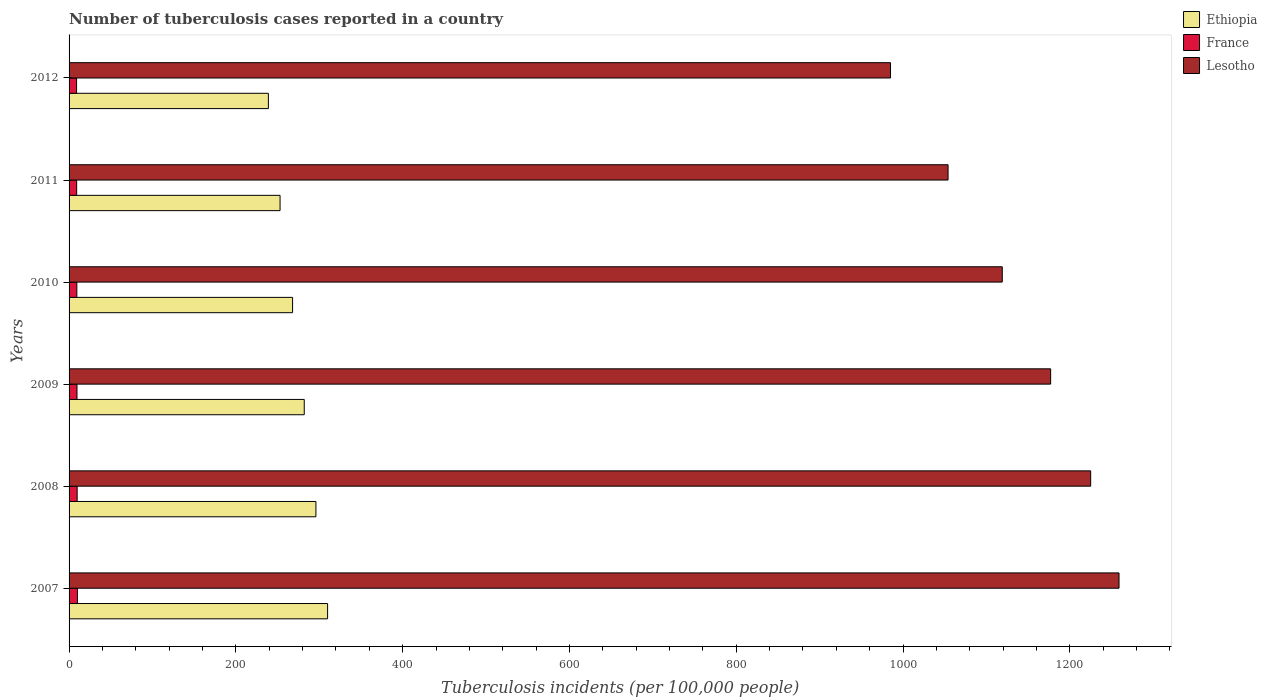How many different coloured bars are there?
Offer a very short reply. 3. Are the number of bars on each tick of the Y-axis equal?
Your answer should be very brief. Yes. How many bars are there on the 2nd tick from the top?
Give a very brief answer. 3. What is the label of the 4th group of bars from the top?
Your answer should be very brief. 2009. What is the number of tuberculosis cases reported in in France in 2009?
Ensure brevity in your answer.  9.5. Across all years, what is the maximum number of tuberculosis cases reported in in Lesotho?
Keep it short and to the point. 1259. In which year was the number of tuberculosis cases reported in in Ethiopia maximum?
Your answer should be compact. 2007. In which year was the number of tuberculosis cases reported in in Lesotho minimum?
Give a very brief answer. 2012. What is the total number of tuberculosis cases reported in in Lesotho in the graph?
Keep it short and to the point. 6819. What is the difference between the number of tuberculosis cases reported in in France in 2008 and that in 2010?
Your response must be concise. 0.4. What is the difference between the number of tuberculosis cases reported in in France in 2010 and the number of tuberculosis cases reported in in Ethiopia in 2012?
Your answer should be compact. -229.7. What is the average number of tuberculosis cases reported in in France per year?
Ensure brevity in your answer.  9.43. In the year 2009, what is the difference between the number of tuberculosis cases reported in in France and number of tuberculosis cases reported in in Lesotho?
Your answer should be compact. -1167.5. In how many years, is the number of tuberculosis cases reported in in France greater than 120 ?
Provide a succinct answer. 0. What is the ratio of the number of tuberculosis cases reported in in Lesotho in 2009 to that in 2012?
Make the answer very short. 1.19. What is the difference between the highest and the second highest number of tuberculosis cases reported in in Ethiopia?
Make the answer very short. 14. What is the difference between the highest and the lowest number of tuberculosis cases reported in in Ethiopia?
Give a very brief answer. 71. What does the 3rd bar from the top in 2007 represents?
Provide a short and direct response. Ethiopia. How many bars are there?
Your answer should be compact. 18. Are all the bars in the graph horizontal?
Keep it short and to the point. Yes. How many years are there in the graph?
Make the answer very short. 6. What is the difference between two consecutive major ticks on the X-axis?
Ensure brevity in your answer.  200. Are the values on the major ticks of X-axis written in scientific E-notation?
Keep it short and to the point. No. Where does the legend appear in the graph?
Give a very brief answer. Top right. How many legend labels are there?
Your answer should be compact. 3. How are the legend labels stacked?
Offer a very short reply. Vertical. What is the title of the graph?
Offer a terse response. Number of tuberculosis cases reported in a country. What is the label or title of the X-axis?
Your answer should be compact. Tuberculosis incidents (per 100,0 people). What is the Tuberculosis incidents (per 100,000 people) in Ethiopia in 2007?
Give a very brief answer. 310. What is the Tuberculosis incidents (per 100,000 people) of France in 2007?
Offer a terse response. 10. What is the Tuberculosis incidents (per 100,000 people) of Lesotho in 2007?
Provide a short and direct response. 1259. What is the Tuberculosis incidents (per 100,000 people) of Ethiopia in 2008?
Provide a short and direct response. 296. What is the Tuberculosis incidents (per 100,000 people) in France in 2008?
Offer a very short reply. 9.7. What is the Tuberculosis incidents (per 100,000 people) of Lesotho in 2008?
Give a very brief answer. 1225. What is the Tuberculosis incidents (per 100,000 people) in Ethiopia in 2009?
Provide a short and direct response. 282. What is the Tuberculosis incidents (per 100,000 people) of France in 2009?
Provide a short and direct response. 9.5. What is the Tuberculosis incidents (per 100,000 people) of Lesotho in 2009?
Your response must be concise. 1177. What is the Tuberculosis incidents (per 100,000 people) of Ethiopia in 2010?
Make the answer very short. 268. What is the Tuberculosis incidents (per 100,000 people) of Lesotho in 2010?
Provide a short and direct response. 1119. What is the Tuberculosis incidents (per 100,000 people) in Ethiopia in 2011?
Provide a succinct answer. 253. What is the Tuberculosis incidents (per 100,000 people) of Lesotho in 2011?
Your answer should be compact. 1054. What is the Tuberculosis incidents (per 100,000 people) in Ethiopia in 2012?
Ensure brevity in your answer.  239. What is the Tuberculosis incidents (per 100,000 people) in Lesotho in 2012?
Make the answer very short. 985. Across all years, what is the maximum Tuberculosis incidents (per 100,000 people) of Ethiopia?
Provide a succinct answer. 310. Across all years, what is the maximum Tuberculosis incidents (per 100,000 people) in France?
Keep it short and to the point. 10. Across all years, what is the maximum Tuberculosis incidents (per 100,000 people) in Lesotho?
Provide a succinct answer. 1259. Across all years, what is the minimum Tuberculosis incidents (per 100,000 people) in Ethiopia?
Offer a terse response. 239. Across all years, what is the minimum Tuberculosis incidents (per 100,000 people) in France?
Offer a terse response. 9. Across all years, what is the minimum Tuberculosis incidents (per 100,000 people) in Lesotho?
Ensure brevity in your answer.  985. What is the total Tuberculosis incidents (per 100,000 people) of Ethiopia in the graph?
Offer a terse response. 1648. What is the total Tuberculosis incidents (per 100,000 people) of France in the graph?
Give a very brief answer. 56.6. What is the total Tuberculosis incidents (per 100,000 people) of Lesotho in the graph?
Your answer should be very brief. 6819. What is the difference between the Tuberculosis incidents (per 100,000 people) in France in 2007 and that in 2008?
Ensure brevity in your answer.  0.3. What is the difference between the Tuberculosis incidents (per 100,000 people) in France in 2007 and that in 2009?
Offer a very short reply. 0.5. What is the difference between the Tuberculosis incidents (per 100,000 people) of Lesotho in 2007 and that in 2009?
Ensure brevity in your answer.  82. What is the difference between the Tuberculosis incidents (per 100,000 people) in Ethiopia in 2007 and that in 2010?
Your answer should be compact. 42. What is the difference between the Tuberculosis incidents (per 100,000 people) of France in 2007 and that in 2010?
Offer a terse response. 0.7. What is the difference between the Tuberculosis incidents (per 100,000 people) in Lesotho in 2007 and that in 2010?
Ensure brevity in your answer.  140. What is the difference between the Tuberculosis incidents (per 100,000 people) in Ethiopia in 2007 and that in 2011?
Offer a very short reply. 57. What is the difference between the Tuberculosis incidents (per 100,000 people) in France in 2007 and that in 2011?
Offer a terse response. 0.9. What is the difference between the Tuberculosis incidents (per 100,000 people) of Lesotho in 2007 and that in 2011?
Your answer should be very brief. 205. What is the difference between the Tuberculosis incidents (per 100,000 people) in France in 2007 and that in 2012?
Offer a very short reply. 1. What is the difference between the Tuberculosis incidents (per 100,000 people) of Lesotho in 2007 and that in 2012?
Ensure brevity in your answer.  274. What is the difference between the Tuberculosis incidents (per 100,000 people) of Ethiopia in 2008 and that in 2009?
Your response must be concise. 14. What is the difference between the Tuberculosis incidents (per 100,000 people) of France in 2008 and that in 2009?
Provide a succinct answer. 0.2. What is the difference between the Tuberculosis incidents (per 100,000 people) in Lesotho in 2008 and that in 2009?
Keep it short and to the point. 48. What is the difference between the Tuberculosis incidents (per 100,000 people) of France in 2008 and that in 2010?
Offer a very short reply. 0.4. What is the difference between the Tuberculosis incidents (per 100,000 people) in Lesotho in 2008 and that in 2010?
Make the answer very short. 106. What is the difference between the Tuberculosis incidents (per 100,000 people) of Ethiopia in 2008 and that in 2011?
Provide a succinct answer. 43. What is the difference between the Tuberculosis incidents (per 100,000 people) in Lesotho in 2008 and that in 2011?
Your answer should be very brief. 171. What is the difference between the Tuberculosis incidents (per 100,000 people) of Ethiopia in 2008 and that in 2012?
Ensure brevity in your answer.  57. What is the difference between the Tuberculosis incidents (per 100,000 people) in France in 2008 and that in 2012?
Provide a succinct answer. 0.7. What is the difference between the Tuberculosis incidents (per 100,000 people) of Lesotho in 2008 and that in 2012?
Offer a very short reply. 240. What is the difference between the Tuberculosis incidents (per 100,000 people) of France in 2009 and that in 2010?
Your answer should be very brief. 0.2. What is the difference between the Tuberculosis incidents (per 100,000 people) in Lesotho in 2009 and that in 2010?
Offer a terse response. 58. What is the difference between the Tuberculosis incidents (per 100,000 people) in France in 2009 and that in 2011?
Offer a very short reply. 0.4. What is the difference between the Tuberculosis incidents (per 100,000 people) of Lesotho in 2009 and that in 2011?
Offer a terse response. 123. What is the difference between the Tuberculosis incidents (per 100,000 people) of Ethiopia in 2009 and that in 2012?
Your answer should be compact. 43. What is the difference between the Tuberculosis incidents (per 100,000 people) of France in 2009 and that in 2012?
Offer a very short reply. 0.5. What is the difference between the Tuberculosis incidents (per 100,000 people) of Lesotho in 2009 and that in 2012?
Provide a short and direct response. 192. What is the difference between the Tuberculosis incidents (per 100,000 people) in France in 2010 and that in 2011?
Your answer should be compact. 0.2. What is the difference between the Tuberculosis incidents (per 100,000 people) of Ethiopia in 2010 and that in 2012?
Provide a short and direct response. 29. What is the difference between the Tuberculosis incidents (per 100,000 people) of France in 2010 and that in 2012?
Keep it short and to the point. 0.3. What is the difference between the Tuberculosis incidents (per 100,000 people) of Lesotho in 2010 and that in 2012?
Your response must be concise. 134. What is the difference between the Tuberculosis incidents (per 100,000 people) of Ethiopia in 2011 and that in 2012?
Your answer should be very brief. 14. What is the difference between the Tuberculosis incidents (per 100,000 people) in France in 2011 and that in 2012?
Make the answer very short. 0.1. What is the difference between the Tuberculosis incidents (per 100,000 people) in Lesotho in 2011 and that in 2012?
Give a very brief answer. 69. What is the difference between the Tuberculosis incidents (per 100,000 people) of Ethiopia in 2007 and the Tuberculosis incidents (per 100,000 people) of France in 2008?
Ensure brevity in your answer.  300.3. What is the difference between the Tuberculosis incidents (per 100,000 people) in Ethiopia in 2007 and the Tuberculosis incidents (per 100,000 people) in Lesotho in 2008?
Your answer should be compact. -915. What is the difference between the Tuberculosis incidents (per 100,000 people) of France in 2007 and the Tuberculosis incidents (per 100,000 people) of Lesotho in 2008?
Provide a short and direct response. -1215. What is the difference between the Tuberculosis incidents (per 100,000 people) of Ethiopia in 2007 and the Tuberculosis incidents (per 100,000 people) of France in 2009?
Provide a succinct answer. 300.5. What is the difference between the Tuberculosis incidents (per 100,000 people) in Ethiopia in 2007 and the Tuberculosis incidents (per 100,000 people) in Lesotho in 2009?
Make the answer very short. -867. What is the difference between the Tuberculosis incidents (per 100,000 people) of France in 2007 and the Tuberculosis incidents (per 100,000 people) of Lesotho in 2009?
Make the answer very short. -1167. What is the difference between the Tuberculosis incidents (per 100,000 people) of Ethiopia in 2007 and the Tuberculosis incidents (per 100,000 people) of France in 2010?
Keep it short and to the point. 300.7. What is the difference between the Tuberculosis incidents (per 100,000 people) in Ethiopia in 2007 and the Tuberculosis incidents (per 100,000 people) in Lesotho in 2010?
Your answer should be compact. -809. What is the difference between the Tuberculosis incidents (per 100,000 people) in France in 2007 and the Tuberculosis incidents (per 100,000 people) in Lesotho in 2010?
Give a very brief answer. -1109. What is the difference between the Tuberculosis incidents (per 100,000 people) of Ethiopia in 2007 and the Tuberculosis incidents (per 100,000 people) of France in 2011?
Offer a terse response. 300.9. What is the difference between the Tuberculosis incidents (per 100,000 people) of Ethiopia in 2007 and the Tuberculosis incidents (per 100,000 people) of Lesotho in 2011?
Provide a short and direct response. -744. What is the difference between the Tuberculosis incidents (per 100,000 people) of France in 2007 and the Tuberculosis incidents (per 100,000 people) of Lesotho in 2011?
Provide a succinct answer. -1044. What is the difference between the Tuberculosis incidents (per 100,000 people) in Ethiopia in 2007 and the Tuberculosis incidents (per 100,000 people) in France in 2012?
Your answer should be very brief. 301. What is the difference between the Tuberculosis incidents (per 100,000 people) in Ethiopia in 2007 and the Tuberculosis incidents (per 100,000 people) in Lesotho in 2012?
Ensure brevity in your answer.  -675. What is the difference between the Tuberculosis incidents (per 100,000 people) of France in 2007 and the Tuberculosis incidents (per 100,000 people) of Lesotho in 2012?
Provide a short and direct response. -975. What is the difference between the Tuberculosis incidents (per 100,000 people) of Ethiopia in 2008 and the Tuberculosis incidents (per 100,000 people) of France in 2009?
Your response must be concise. 286.5. What is the difference between the Tuberculosis incidents (per 100,000 people) of Ethiopia in 2008 and the Tuberculosis incidents (per 100,000 people) of Lesotho in 2009?
Ensure brevity in your answer.  -881. What is the difference between the Tuberculosis incidents (per 100,000 people) in France in 2008 and the Tuberculosis incidents (per 100,000 people) in Lesotho in 2009?
Make the answer very short. -1167.3. What is the difference between the Tuberculosis incidents (per 100,000 people) of Ethiopia in 2008 and the Tuberculosis incidents (per 100,000 people) of France in 2010?
Provide a short and direct response. 286.7. What is the difference between the Tuberculosis incidents (per 100,000 people) in Ethiopia in 2008 and the Tuberculosis incidents (per 100,000 people) in Lesotho in 2010?
Provide a succinct answer. -823. What is the difference between the Tuberculosis incidents (per 100,000 people) in France in 2008 and the Tuberculosis incidents (per 100,000 people) in Lesotho in 2010?
Ensure brevity in your answer.  -1109.3. What is the difference between the Tuberculosis incidents (per 100,000 people) of Ethiopia in 2008 and the Tuberculosis incidents (per 100,000 people) of France in 2011?
Offer a very short reply. 286.9. What is the difference between the Tuberculosis incidents (per 100,000 people) of Ethiopia in 2008 and the Tuberculosis incidents (per 100,000 people) of Lesotho in 2011?
Give a very brief answer. -758. What is the difference between the Tuberculosis incidents (per 100,000 people) in France in 2008 and the Tuberculosis incidents (per 100,000 people) in Lesotho in 2011?
Give a very brief answer. -1044.3. What is the difference between the Tuberculosis incidents (per 100,000 people) in Ethiopia in 2008 and the Tuberculosis incidents (per 100,000 people) in France in 2012?
Your answer should be very brief. 287. What is the difference between the Tuberculosis incidents (per 100,000 people) in Ethiopia in 2008 and the Tuberculosis incidents (per 100,000 people) in Lesotho in 2012?
Provide a succinct answer. -689. What is the difference between the Tuberculosis incidents (per 100,000 people) of France in 2008 and the Tuberculosis incidents (per 100,000 people) of Lesotho in 2012?
Keep it short and to the point. -975.3. What is the difference between the Tuberculosis incidents (per 100,000 people) of Ethiopia in 2009 and the Tuberculosis incidents (per 100,000 people) of France in 2010?
Offer a terse response. 272.7. What is the difference between the Tuberculosis incidents (per 100,000 people) in Ethiopia in 2009 and the Tuberculosis incidents (per 100,000 people) in Lesotho in 2010?
Keep it short and to the point. -837. What is the difference between the Tuberculosis incidents (per 100,000 people) of France in 2009 and the Tuberculosis incidents (per 100,000 people) of Lesotho in 2010?
Offer a very short reply. -1109.5. What is the difference between the Tuberculosis incidents (per 100,000 people) of Ethiopia in 2009 and the Tuberculosis incidents (per 100,000 people) of France in 2011?
Your answer should be very brief. 272.9. What is the difference between the Tuberculosis incidents (per 100,000 people) in Ethiopia in 2009 and the Tuberculosis incidents (per 100,000 people) in Lesotho in 2011?
Your response must be concise. -772. What is the difference between the Tuberculosis incidents (per 100,000 people) in France in 2009 and the Tuberculosis incidents (per 100,000 people) in Lesotho in 2011?
Give a very brief answer. -1044.5. What is the difference between the Tuberculosis incidents (per 100,000 people) of Ethiopia in 2009 and the Tuberculosis incidents (per 100,000 people) of France in 2012?
Your response must be concise. 273. What is the difference between the Tuberculosis incidents (per 100,000 people) of Ethiopia in 2009 and the Tuberculosis incidents (per 100,000 people) of Lesotho in 2012?
Your response must be concise. -703. What is the difference between the Tuberculosis incidents (per 100,000 people) of France in 2009 and the Tuberculosis incidents (per 100,000 people) of Lesotho in 2012?
Make the answer very short. -975.5. What is the difference between the Tuberculosis incidents (per 100,000 people) of Ethiopia in 2010 and the Tuberculosis incidents (per 100,000 people) of France in 2011?
Offer a very short reply. 258.9. What is the difference between the Tuberculosis incidents (per 100,000 people) in Ethiopia in 2010 and the Tuberculosis incidents (per 100,000 people) in Lesotho in 2011?
Give a very brief answer. -786. What is the difference between the Tuberculosis incidents (per 100,000 people) of France in 2010 and the Tuberculosis incidents (per 100,000 people) of Lesotho in 2011?
Provide a succinct answer. -1044.7. What is the difference between the Tuberculosis incidents (per 100,000 people) in Ethiopia in 2010 and the Tuberculosis incidents (per 100,000 people) in France in 2012?
Your answer should be very brief. 259. What is the difference between the Tuberculosis incidents (per 100,000 people) of Ethiopia in 2010 and the Tuberculosis incidents (per 100,000 people) of Lesotho in 2012?
Offer a terse response. -717. What is the difference between the Tuberculosis incidents (per 100,000 people) of France in 2010 and the Tuberculosis incidents (per 100,000 people) of Lesotho in 2012?
Keep it short and to the point. -975.7. What is the difference between the Tuberculosis incidents (per 100,000 people) of Ethiopia in 2011 and the Tuberculosis incidents (per 100,000 people) of France in 2012?
Make the answer very short. 244. What is the difference between the Tuberculosis incidents (per 100,000 people) in Ethiopia in 2011 and the Tuberculosis incidents (per 100,000 people) in Lesotho in 2012?
Offer a terse response. -732. What is the difference between the Tuberculosis incidents (per 100,000 people) of France in 2011 and the Tuberculosis incidents (per 100,000 people) of Lesotho in 2012?
Ensure brevity in your answer.  -975.9. What is the average Tuberculosis incidents (per 100,000 people) of Ethiopia per year?
Offer a very short reply. 274.67. What is the average Tuberculosis incidents (per 100,000 people) of France per year?
Provide a succinct answer. 9.43. What is the average Tuberculosis incidents (per 100,000 people) of Lesotho per year?
Your response must be concise. 1136.5. In the year 2007, what is the difference between the Tuberculosis incidents (per 100,000 people) of Ethiopia and Tuberculosis incidents (per 100,000 people) of France?
Make the answer very short. 300. In the year 2007, what is the difference between the Tuberculosis incidents (per 100,000 people) in Ethiopia and Tuberculosis incidents (per 100,000 people) in Lesotho?
Keep it short and to the point. -949. In the year 2007, what is the difference between the Tuberculosis incidents (per 100,000 people) in France and Tuberculosis incidents (per 100,000 people) in Lesotho?
Ensure brevity in your answer.  -1249. In the year 2008, what is the difference between the Tuberculosis incidents (per 100,000 people) in Ethiopia and Tuberculosis incidents (per 100,000 people) in France?
Make the answer very short. 286.3. In the year 2008, what is the difference between the Tuberculosis incidents (per 100,000 people) in Ethiopia and Tuberculosis incidents (per 100,000 people) in Lesotho?
Your response must be concise. -929. In the year 2008, what is the difference between the Tuberculosis incidents (per 100,000 people) in France and Tuberculosis incidents (per 100,000 people) in Lesotho?
Ensure brevity in your answer.  -1215.3. In the year 2009, what is the difference between the Tuberculosis incidents (per 100,000 people) in Ethiopia and Tuberculosis incidents (per 100,000 people) in France?
Offer a terse response. 272.5. In the year 2009, what is the difference between the Tuberculosis incidents (per 100,000 people) in Ethiopia and Tuberculosis incidents (per 100,000 people) in Lesotho?
Your response must be concise. -895. In the year 2009, what is the difference between the Tuberculosis incidents (per 100,000 people) in France and Tuberculosis incidents (per 100,000 people) in Lesotho?
Your response must be concise. -1167.5. In the year 2010, what is the difference between the Tuberculosis incidents (per 100,000 people) in Ethiopia and Tuberculosis incidents (per 100,000 people) in France?
Your response must be concise. 258.7. In the year 2010, what is the difference between the Tuberculosis incidents (per 100,000 people) of Ethiopia and Tuberculosis incidents (per 100,000 people) of Lesotho?
Provide a succinct answer. -851. In the year 2010, what is the difference between the Tuberculosis incidents (per 100,000 people) in France and Tuberculosis incidents (per 100,000 people) in Lesotho?
Make the answer very short. -1109.7. In the year 2011, what is the difference between the Tuberculosis incidents (per 100,000 people) of Ethiopia and Tuberculosis incidents (per 100,000 people) of France?
Provide a short and direct response. 243.9. In the year 2011, what is the difference between the Tuberculosis incidents (per 100,000 people) of Ethiopia and Tuberculosis incidents (per 100,000 people) of Lesotho?
Provide a short and direct response. -801. In the year 2011, what is the difference between the Tuberculosis incidents (per 100,000 people) of France and Tuberculosis incidents (per 100,000 people) of Lesotho?
Ensure brevity in your answer.  -1044.9. In the year 2012, what is the difference between the Tuberculosis incidents (per 100,000 people) of Ethiopia and Tuberculosis incidents (per 100,000 people) of France?
Provide a short and direct response. 230. In the year 2012, what is the difference between the Tuberculosis incidents (per 100,000 people) of Ethiopia and Tuberculosis incidents (per 100,000 people) of Lesotho?
Offer a terse response. -746. In the year 2012, what is the difference between the Tuberculosis incidents (per 100,000 people) in France and Tuberculosis incidents (per 100,000 people) in Lesotho?
Offer a terse response. -976. What is the ratio of the Tuberculosis incidents (per 100,000 people) in Ethiopia in 2007 to that in 2008?
Give a very brief answer. 1.05. What is the ratio of the Tuberculosis incidents (per 100,000 people) of France in 2007 to that in 2008?
Give a very brief answer. 1.03. What is the ratio of the Tuberculosis incidents (per 100,000 people) in Lesotho in 2007 to that in 2008?
Provide a short and direct response. 1.03. What is the ratio of the Tuberculosis incidents (per 100,000 people) in Ethiopia in 2007 to that in 2009?
Your response must be concise. 1.1. What is the ratio of the Tuberculosis incidents (per 100,000 people) in France in 2007 to that in 2009?
Offer a very short reply. 1.05. What is the ratio of the Tuberculosis incidents (per 100,000 people) in Lesotho in 2007 to that in 2009?
Your answer should be very brief. 1.07. What is the ratio of the Tuberculosis incidents (per 100,000 people) in Ethiopia in 2007 to that in 2010?
Keep it short and to the point. 1.16. What is the ratio of the Tuberculosis incidents (per 100,000 people) in France in 2007 to that in 2010?
Your response must be concise. 1.08. What is the ratio of the Tuberculosis incidents (per 100,000 people) of Lesotho in 2007 to that in 2010?
Your response must be concise. 1.13. What is the ratio of the Tuberculosis incidents (per 100,000 people) of Ethiopia in 2007 to that in 2011?
Make the answer very short. 1.23. What is the ratio of the Tuberculosis incidents (per 100,000 people) of France in 2007 to that in 2011?
Keep it short and to the point. 1.1. What is the ratio of the Tuberculosis incidents (per 100,000 people) in Lesotho in 2007 to that in 2011?
Keep it short and to the point. 1.19. What is the ratio of the Tuberculosis incidents (per 100,000 people) in Ethiopia in 2007 to that in 2012?
Your answer should be compact. 1.3. What is the ratio of the Tuberculosis incidents (per 100,000 people) in France in 2007 to that in 2012?
Give a very brief answer. 1.11. What is the ratio of the Tuberculosis incidents (per 100,000 people) of Lesotho in 2007 to that in 2012?
Make the answer very short. 1.28. What is the ratio of the Tuberculosis incidents (per 100,000 people) of Ethiopia in 2008 to that in 2009?
Your answer should be very brief. 1.05. What is the ratio of the Tuberculosis incidents (per 100,000 people) of France in 2008 to that in 2009?
Keep it short and to the point. 1.02. What is the ratio of the Tuberculosis incidents (per 100,000 people) of Lesotho in 2008 to that in 2009?
Offer a terse response. 1.04. What is the ratio of the Tuberculosis incidents (per 100,000 people) in Ethiopia in 2008 to that in 2010?
Give a very brief answer. 1.1. What is the ratio of the Tuberculosis incidents (per 100,000 people) in France in 2008 to that in 2010?
Ensure brevity in your answer.  1.04. What is the ratio of the Tuberculosis incidents (per 100,000 people) in Lesotho in 2008 to that in 2010?
Provide a short and direct response. 1.09. What is the ratio of the Tuberculosis incidents (per 100,000 people) in Ethiopia in 2008 to that in 2011?
Your answer should be compact. 1.17. What is the ratio of the Tuberculosis incidents (per 100,000 people) in France in 2008 to that in 2011?
Offer a very short reply. 1.07. What is the ratio of the Tuberculosis incidents (per 100,000 people) in Lesotho in 2008 to that in 2011?
Ensure brevity in your answer.  1.16. What is the ratio of the Tuberculosis incidents (per 100,000 people) of Ethiopia in 2008 to that in 2012?
Your answer should be compact. 1.24. What is the ratio of the Tuberculosis incidents (per 100,000 people) in France in 2008 to that in 2012?
Your answer should be compact. 1.08. What is the ratio of the Tuberculosis incidents (per 100,000 people) of Lesotho in 2008 to that in 2012?
Your response must be concise. 1.24. What is the ratio of the Tuberculosis incidents (per 100,000 people) of Ethiopia in 2009 to that in 2010?
Provide a succinct answer. 1.05. What is the ratio of the Tuberculosis incidents (per 100,000 people) of France in 2009 to that in 2010?
Provide a succinct answer. 1.02. What is the ratio of the Tuberculosis incidents (per 100,000 people) of Lesotho in 2009 to that in 2010?
Your answer should be compact. 1.05. What is the ratio of the Tuberculosis incidents (per 100,000 people) of Ethiopia in 2009 to that in 2011?
Make the answer very short. 1.11. What is the ratio of the Tuberculosis incidents (per 100,000 people) of France in 2009 to that in 2011?
Give a very brief answer. 1.04. What is the ratio of the Tuberculosis incidents (per 100,000 people) of Lesotho in 2009 to that in 2011?
Make the answer very short. 1.12. What is the ratio of the Tuberculosis incidents (per 100,000 people) of Ethiopia in 2009 to that in 2012?
Your answer should be very brief. 1.18. What is the ratio of the Tuberculosis incidents (per 100,000 people) of France in 2009 to that in 2012?
Your answer should be compact. 1.06. What is the ratio of the Tuberculosis incidents (per 100,000 people) in Lesotho in 2009 to that in 2012?
Provide a succinct answer. 1.19. What is the ratio of the Tuberculosis incidents (per 100,000 people) of Ethiopia in 2010 to that in 2011?
Provide a succinct answer. 1.06. What is the ratio of the Tuberculosis incidents (per 100,000 people) of France in 2010 to that in 2011?
Provide a short and direct response. 1.02. What is the ratio of the Tuberculosis incidents (per 100,000 people) of Lesotho in 2010 to that in 2011?
Your answer should be compact. 1.06. What is the ratio of the Tuberculosis incidents (per 100,000 people) of Ethiopia in 2010 to that in 2012?
Provide a succinct answer. 1.12. What is the ratio of the Tuberculosis incidents (per 100,000 people) in Lesotho in 2010 to that in 2012?
Ensure brevity in your answer.  1.14. What is the ratio of the Tuberculosis incidents (per 100,000 people) of Ethiopia in 2011 to that in 2012?
Ensure brevity in your answer.  1.06. What is the ratio of the Tuberculosis incidents (per 100,000 people) in France in 2011 to that in 2012?
Offer a terse response. 1.01. What is the ratio of the Tuberculosis incidents (per 100,000 people) of Lesotho in 2011 to that in 2012?
Your answer should be compact. 1.07. What is the difference between the highest and the second highest Tuberculosis incidents (per 100,000 people) in France?
Your answer should be very brief. 0.3. What is the difference between the highest and the lowest Tuberculosis incidents (per 100,000 people) of France?
Ensure brevity in your answer.  1. What is the difference between the highest and the lowest Tuberculosis incidents (per 100,000 people) in Lesotho?
Offer a very short reply. 274. 